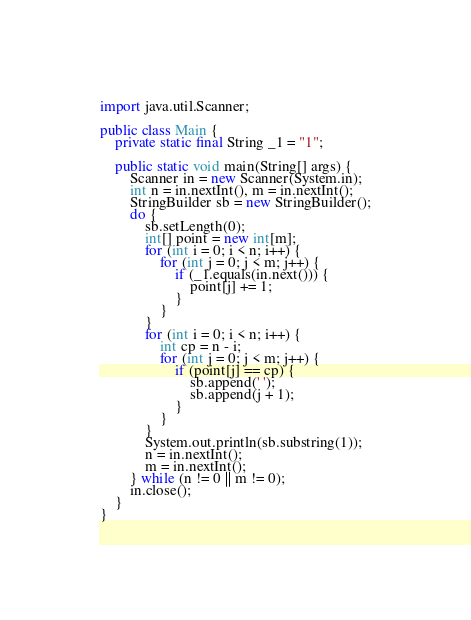Convert code to text. <code><loc_0><loc_0><loc_500><loc_500><_Java_>import java.util.Scanner;

public class Main {
	private static final String _1 = "1";

	public static void main(String[] args) {
		Scanner in = new Scanner(System.in);
		int n = in.nextInt(), m = in.nextInt();
		StringBuilder sb = new StringBuilder();
		do {
			sb.setLength(0);
			int[] point = new int[m];
			for (int i = 0; i < n; i++) {
				for (int j = 0; j < m; j++) {
					if (_1.equals(in.next())) {
						point[j] += 1;
					}
				}
			}
			for (int i = 0; i < n; i++) {
				int cp = n - i;
				for (int j = 0; j < m; j++) {
					if (point[j] == cp) {
						sb.append(' ');
						sb.append(j + 1);
					}
				}
			}
			System.out.println(sb.substring(1));
			n = in.nextInt();
			m = in.nextInt();
		} while (n != 0 || m != 0);
		in.close();
	}
}</code> 